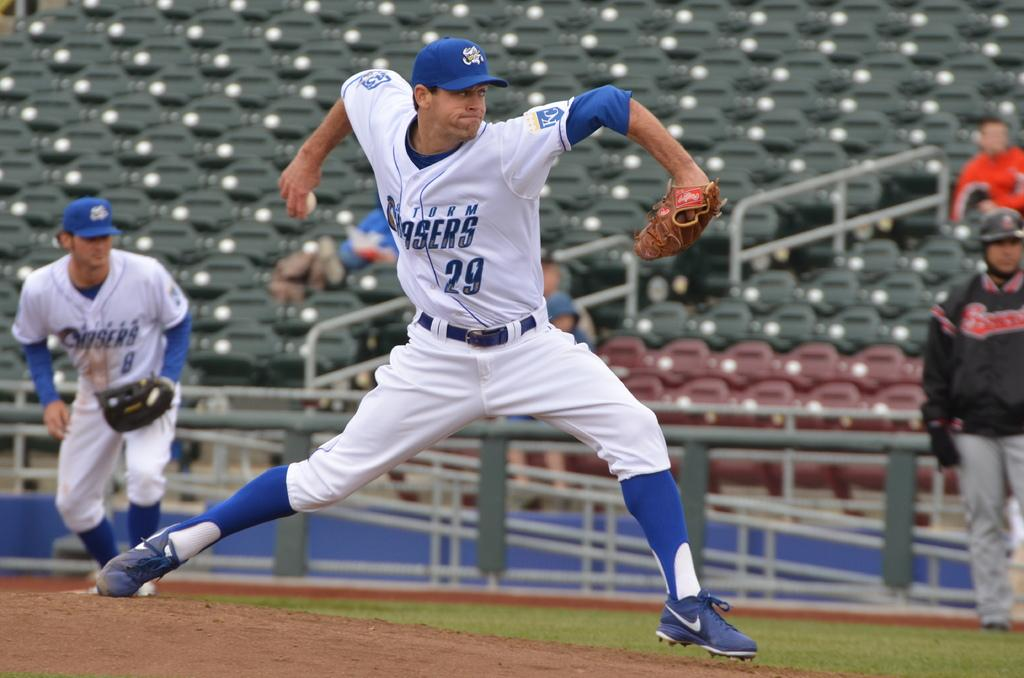<image>
Present a compact description of the photo's key features. a pitcher that has the number 29 on his jersey 